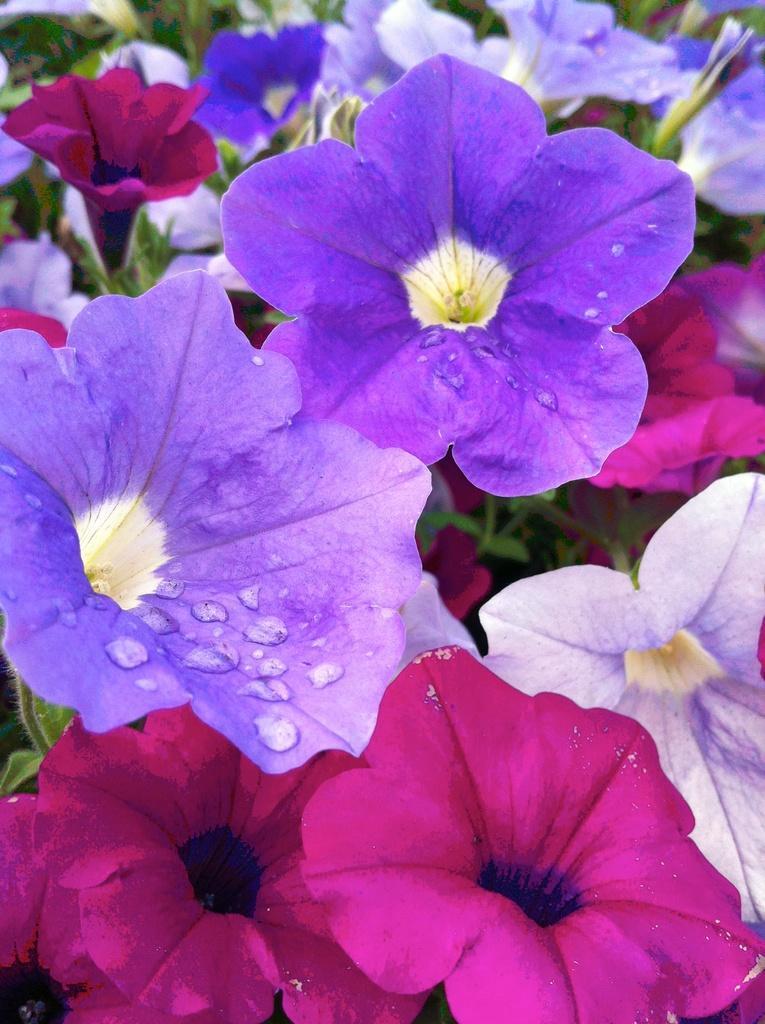How would you summarize this image in a sentence or two? In this image I can see few flowers which are pink and blue in color and few other flowers which are violet and cream in color. In the background I can see few plants which are green in color. 